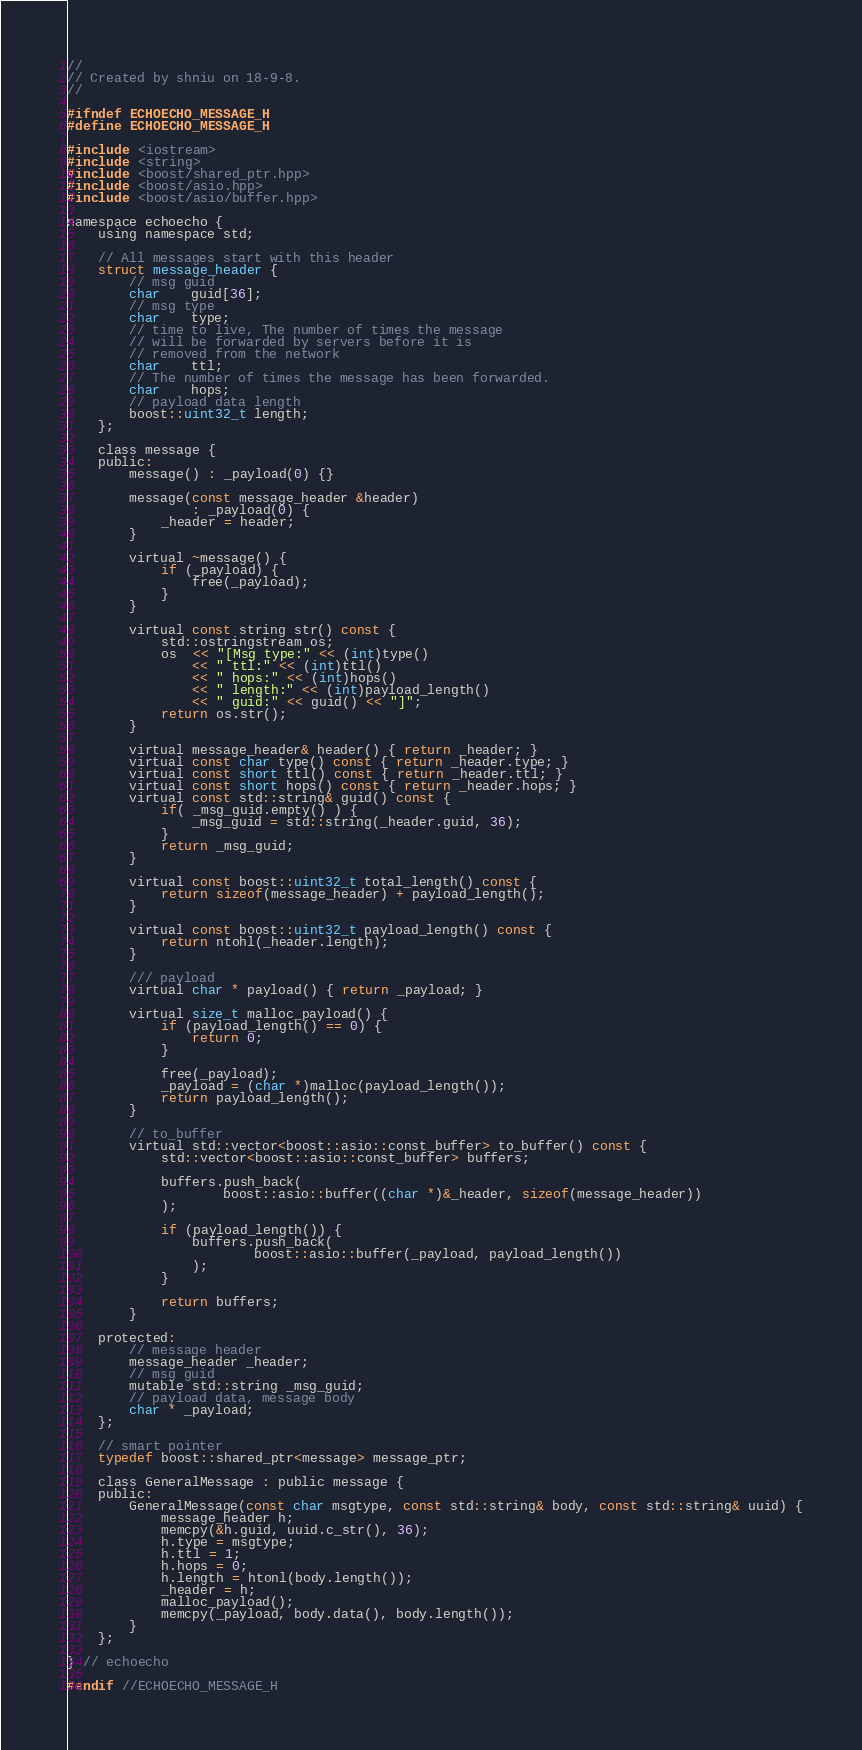Convert code to text. <code><loc_0><loc_0><loc_500><loc_500><_C_>//
// Created by shniu on 18-9-8.
//

#ifndef ECHOECHO_MESSAGE_H
#define ECHOECHO_MESSAGE_H

#include <iostream>
#include <string>
#include <boost/shared_ptr.hpp>
#include <boost/asio.hpp>
#include <boost/asio/buffer.hpp>

namespace echoecho {
    using namespace std;

    // All messages start with this header
    struct message_header {
        // msg guid
        char    guid[36];
        // msg type
        char    type;
        // time to live, The number of times the message
        // will be forwarded by servers before it is
        // removed from the network
        char    ttl;
        // The number of times the message has been forwarded.
        char    hops;
        // payload data length
        boost::uint32_t length;
    };

    class message {
    public:
        message() : _payload(0) {}

        message(const message_header &header)
                : _payload(0) {
            _header = header;
        }

        virtual ~message() {
            if (_payload) {
                free(_payload);
            }
        }

        virtual const string str() const {
            std::ostringstream os;
            os  << "[Msg type:" << (int)type()
                << " ttl:" << (int)ttl()
                << " hops:" << (int)hops()
                << " length:" << (int)payload_length()
                << " guid:" << guid() << "]";
            return os.str();
        }

        virtual message_header& header() { return _header; }
        virtual const char type() const { return _header.type; }
        virtual const short ttl() const { return _header.ttl; }
        virtual const short hops() const { return _header.hops; }
        virtual const std::string& guid() const {
            if( _msg_guid.empty() ) {
                _msg_guid = std::string(_header.guid, 36);
            }
            return _msg_guid;
        }

        virtual const boost::uint32_t total_length() const {
            return sizeof(message_header) + payload_length();
        }

        virtual const boost::uint32_t payload_length() const {
            return ntohl(_header.length);
        }

        /// payload
        virtual char * payload() { return _payload; }

        virtual size_t malloc_payload() {
            if (payload_length() == 0) {
                return 0;
            }

            free(_payload);
            _payload = (char *)malloc(payload_length());
            return payload_length();
        }

        // to_buffer
        virtual std::vector<boost::asio::const_buffer> to_buffer() const {
            std::vector<boost::asio::const_buffer> buffers;

            buffers.push_back(
                    boost::asio::buffer((char *)&_header, sizeof(message_header))
            );

            if (payload_length()) {
                buffers.push_back(
                        boost::asio::buffer(_payload, payload_length())
                );
            }

            return buffers;
        }

    protected:
        // message header
        message_header _header;
        // msg guid
        mutable std::string _msg_guid;
        // payload data, message body
        char * _payload;
    };

    // smart pointer
    typedef boost::shared_ptr<message> message_ptr;

    class GeneralMessage : public message {
    public:
        GeneralMessage(const char msgtype, const std::string& body, const std::string& uuid) {
            message_header h;
            memcpy(&h.guid, uuid.c_str(), 36);
            h.type = msgtype;
            h.ttl = 1;
            h.hops = 0;
            h.length = htonl(body.length());
            _header = h;
            malloc_payload();
            memcpy(_payload, body.data(), body.length());
        }
    };

} // echoecho

#endif //ECHOECHO_MESSAGE_H
</code> 